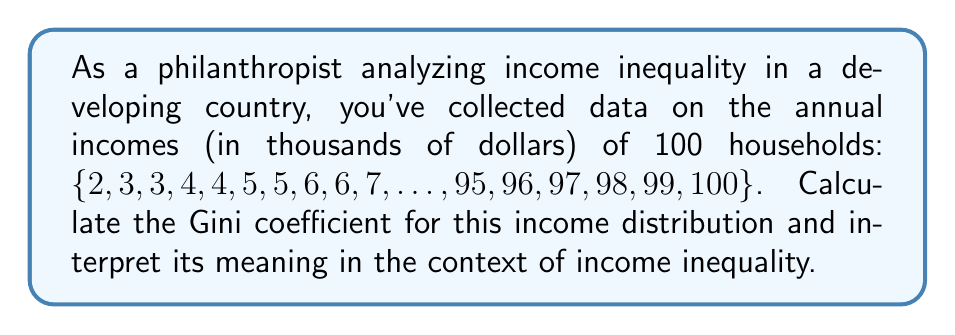Can you answer this question? To calculate the Gini coefficient, we'll follow these steps:

1) First, we need to calculate the mean income:
   $$\mu = \frac{\sum_{i=1}^{100} x_i}{100} = \frac{5050}{100} = 50.5$$

2) Next, we calculate the absolute mean difference:
   $$\text{AMD} = \frac{\sum_{i=1}^{100}\sum_{j=1}^{100} |x_i - x_j|}{100^2}$$

   This involves comparing each income to every other income, taking the absolute difference, summing all these differences, and dividing by the square of the number of households.

3) For this arithmetic sequence, we can use a formula for the AMD:
   $$\text{AMD} = \frac{(b-a)(n+1)}{3n}$$
   where $a$ is the first term (2), $b$ is the last term (100), and $n$ is the number of terms (100).

   $$\text{AMD} = \frac{(100-2)(100+1)}{3(100)} = 33$$

4) Now we can calculate the Gini coefficient:
   $$G = \frac{\text{AMD}}{2\mu} = \frac{33}{2(50.5)} = 0.327$$

5) Interpretation: The Gini coefficient ranges from 0 (perfect equality) to 1 (perfect inequality). A value of 0.327 indicates a moderate level of income inequality. In this context, it suggests that while there is some disparity in incomes, it's not extremely severe. However, there's still significant room for improvement in terms of income distribution.
Answer: Gini coefficient = 0.327, indicating moderate income inequality 